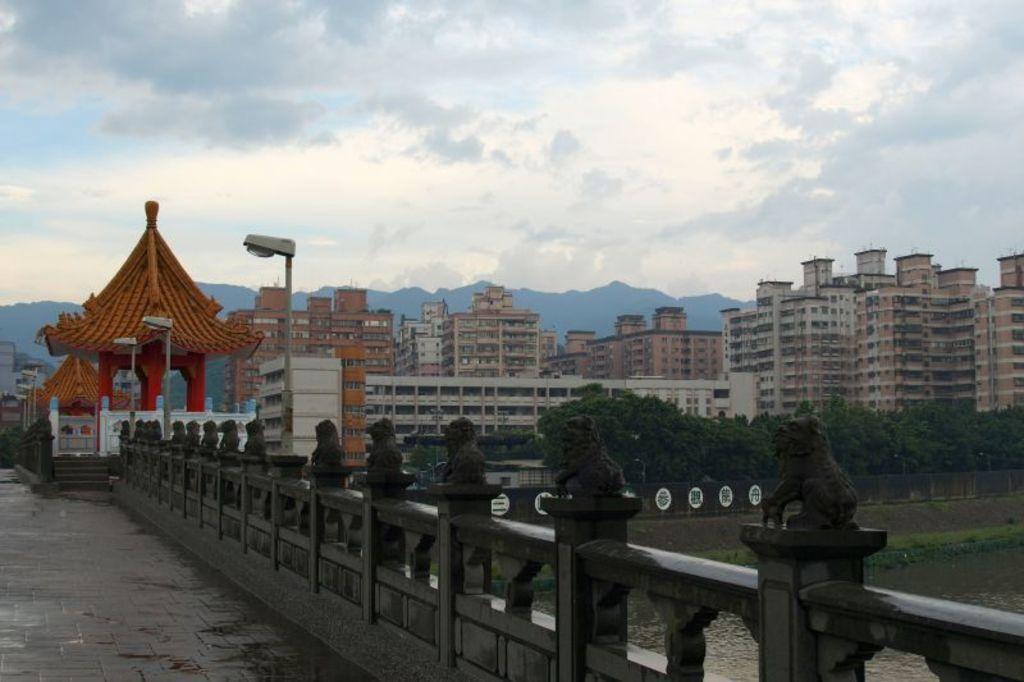Describe this image in one or two sentences. In this picture I can see many buildings and trees. At the bottom I can see the fencing on the bridge. On the right I can see the water flow. On the left I can see the streetlights and hut. In the background I can see the mountains. At the the top I can see the sky and clouds. 